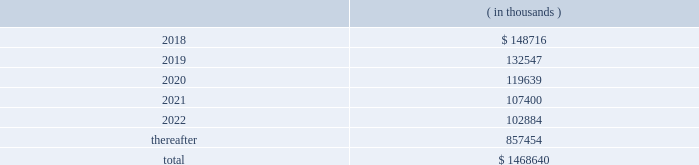Hollyfrontier corporation notes to consolidated financial statements continued .
Transportation and storage costs incurred under these agreements totaled $ 140.5 million , $ 135.1 million and $ 137.7 million for the years ended december 31 , 2017 , 2016 and 2015 , respectively .
These amounts do not include contractual commitments under our long-term transportation agreements with hep , as all transactions with hep are eliminated in these consolidated financial statements .
We have a crude oil supply contract that requires the supplier to deliver a specified volume of crude oil or pay a shortfall fee for the difference in the actual barrels delivered to us less the specified barrels per the supply contract .
For the contract year ended august 31 , 2017 , the actual number of barrels delivered to us was substantially less than the specified barrels , and we recorded a reduction to cost of goods sold and accumulated a shortfall fee receivable of $ 26.0 million during this period .
In september 2017 , the supplier notified us they are disputing the shortfall fee owed and in october 2017 notified us of their demand for arbitration .
We offset the receivable with payments of invoices for deliveries of crude oil received subsequent to august 31 , 2017 , which is permitted under the supply contract .
We believe the disputes and claims made by the supplier are without merit .
In march , 2006 , a subsidiary of ours sold the assets of montana refining company under an asset purchase agreement ( 201capa 201d ) .
Calumet montana refining llc , the current owner of the assets , has submitted requests for reimbursement of approximately $ 20.0 million pursuant to contractual indemnity provisions under the apa for various costs incurred , as well as additional claims related to environmental matters .
We have rejected most of the claims for payment , and this matter is scheduled for arbitration beginning in july 2018 .
We have accrued the costs we believe are owed pursuant to the apa , and we estimate that any reasonably possible losses beyond the amounts accrued are not material .
Note 20 : segment information effective fourth quarter of 2017 , we revised our reportable segments to align with certain changes in how our chief operating decision maker manages and allocates resources to our business .
Accordingly , our tulsa refineries 2019 lubricants operations , previously reported in the refining segment , are now combined with the operations of our petro-canada lubricants business ( acquired february 1 , 2017 ) and reported in the lubricants and specialty products segment .
Our prior period segment information has been retrospectively adjusted to reflect our current segment presentation .
Our operations are organized into three reportable segments , refining , lubricants and specialty products and hep .
Our operations that are not included in the refining , lubricants and specialty products and hep segments are included in corporate and other .
Intersegment transactions are eliminated in our consolidated financial statements and are included in eliminations .
Corporate and other and eliminations are aggregated and presented under corporate , other and eliminations column .
The refining segment represents the operations of the el dorado , tulsa , navajo , cheyenne and woods cross refineries and hfc asphalt ( aggregated as a reportable segment ) .
Refining activities involve the purchase and refining of crude oil and wholesale and branded marketing of refined products , such as gasoline , diesel fuel and jet fuel .
These petroleum products are primarily marketed in the mid-continent , southwest and rocky mountain regions of the united states .
Hfc asphalt operates various asphalt terminals in arizona , new mexico and oklahoma. .
What percentage of obligations are due in greater than 5 years? 
Computations: (857454 / 1468640)
Answer: 0.58384. 